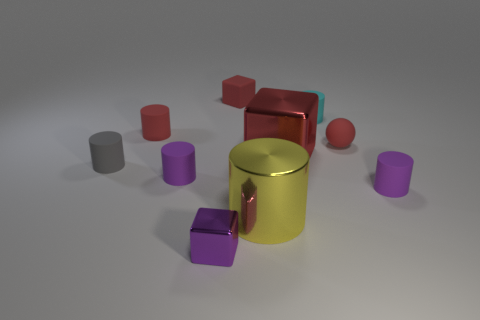How many objects are brown balls or small matte things that are in front of the tiny gray matte object?
Provide a short and direct response. 2. What color is the other block that is made of the same material as the big red cube?
Make the answer very short. Purple. How many things are either big cylinders or green shiny cylinders?
Offer a terse response. 1. The metallic thing that is the same size as the red matte ball is what color?
Your answer should be compact. Purple. How many objects are large yellow metal cylinders that are in front of the big red block or red matte balls?
Your answer should be very brief. 2. What number of other objects are the same size as the rubber cube?
Provide a short and direct response. 7. There is a shiny block behind the large yellow thing; what size is it?
Your response must be concise. Large. There is a gray thing that is the same material as the small cyan thing; what is its shape?
Make the answer very short. Cylinder. Are there any other things that have the same color as the rubber sphere?
Offer a terse response. Yes. The large thing in front of the metal block behind the gray matte cylinder is what color?
Your answer should be compact. Yellow. 